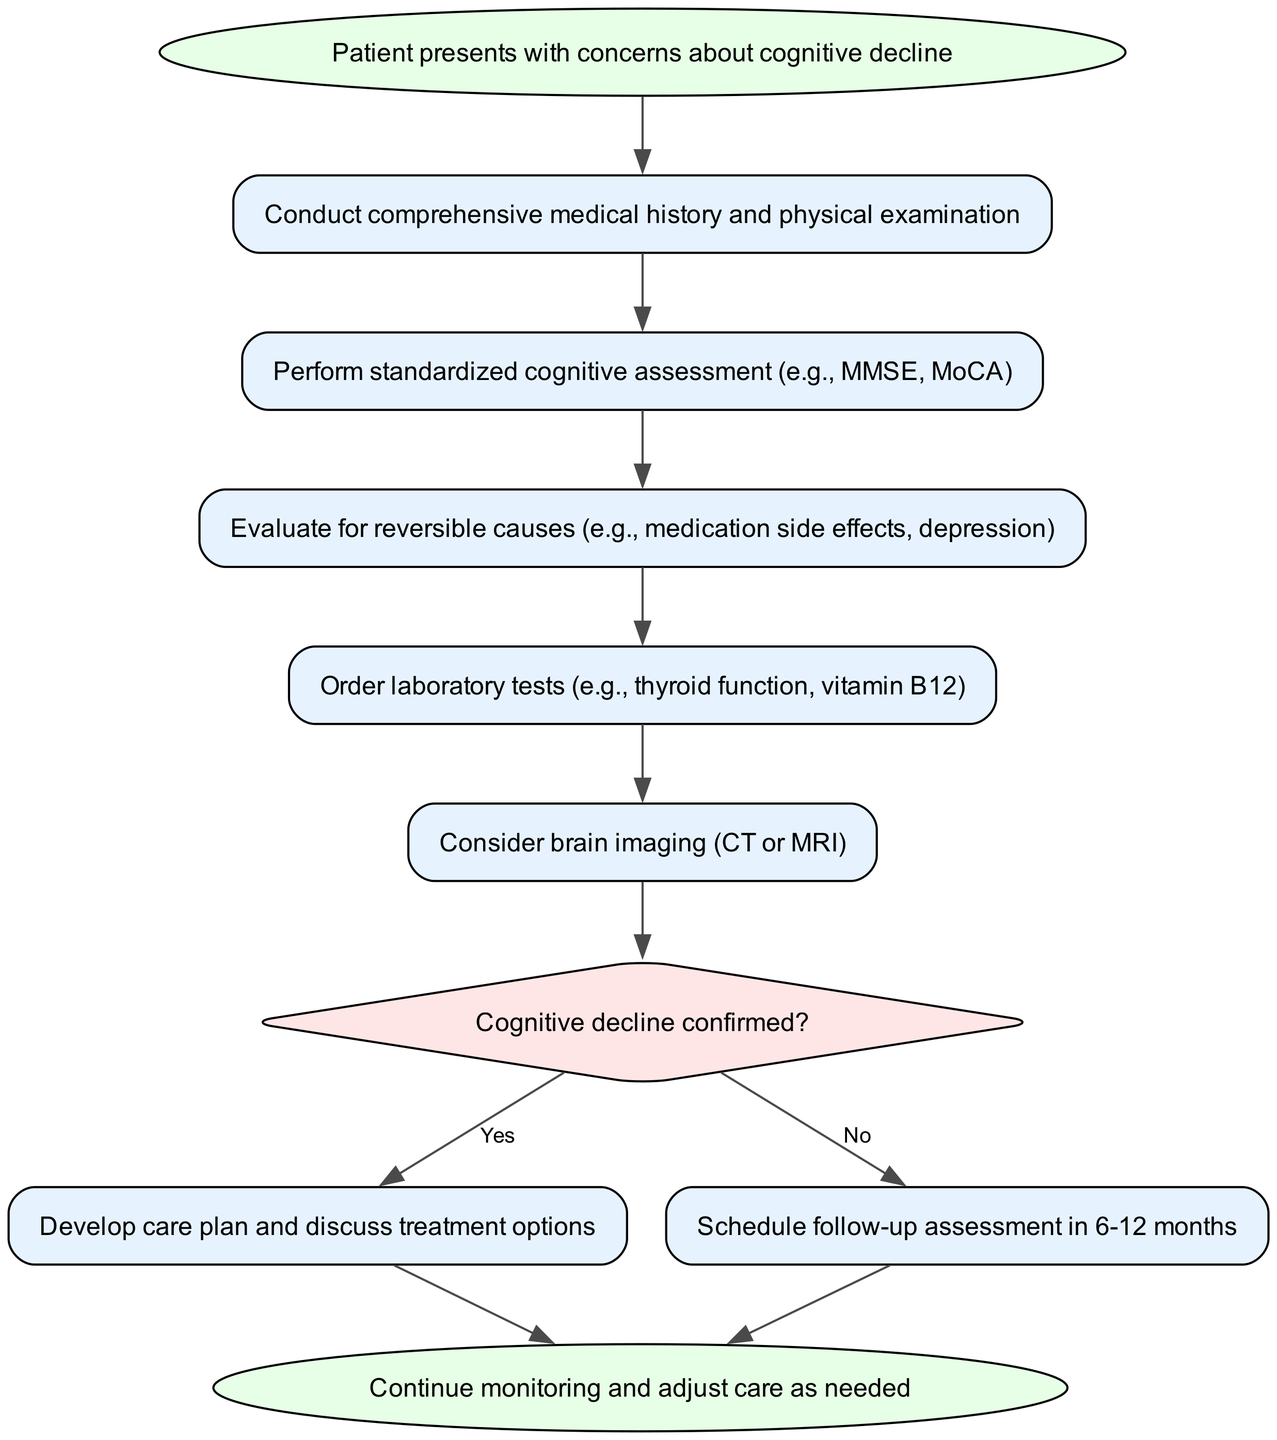What is the first step in the evaluation process? The diagram starts with the node labeled "Patient presents with concerns about cognitive decline," indicating that this is the initial step in the process.
Answer: Patient presents with concerns about cognitive decline How many standardized cognitive assessments are mentioned? The diagram specifies one standardized cognitive assessment, referring to "Perform standardized cognitive assessment (e.g., MMSE, MoCA)," highlighting the types of assessments included in that step.
Answer: One What action follows the evaluation for reversible causes? After evaluating for reversible causes, the next action specified in the diagram is to "Order laboratory tests (e.g., thyroid function, vitamin B12)," which connects directly after the evaluation step.
Answer: Order laboratory tests (e.g., thyroid function, vitamin B12) What does the decision node assess? The decision node is labeled "Cognitive decline confirmed?", indicating that it evaluates whether cognitive decline has been confirmed based on the previous assessments and tests conducted.
Answer: Cognitive decline confirmed? If cognitive decline is confirmed, what is the next step? The diagram indicates that if cognitive decline is confirmed (the "yes" path), the process then directs to "Develop care plan and discuss treatment options," outlining the immediate action to be taken in response to the confirmation.
Answer: Develop care plan and discuss treatment options What is the outcome if cognitive decline is not confirmed? According to the diagram, if cognitive decline is not confirmed (the "no" path), the next outcome is to "Schedule follow-up assessment in 6-12 months," which indicates a monitoring approach.
Answer: Schedule follow-up assessment in 6-12 months How many total nodes are present in the diagram? The diagram contains ten nodes, as counted from the start to the end, including all steps and decision points illustrated in the evaluation process.
Answer: Ten What color represents the decision node? The decision node, which assesses whether cognitive decline is confirmed, is filled with a color labeled "#FFE6E6," setting it apart from other nodes in the diagram for easy identification.
Answer: #FFE6E6 What should be done after the final step regardless of confirmation? The diagram specifies that after reaching either outcome (yes or no), the final action is to "Continue monitoring and adjust care as needed," indicating that patient management remains an ongoing process.
Answer: Continue monitoring and adjust care as needed 